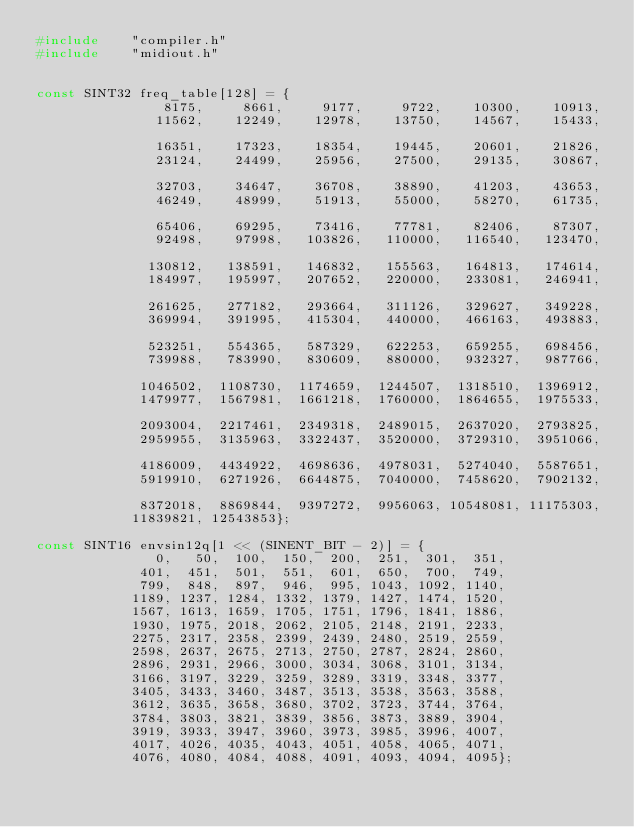<code> <loc_0><loc_0><loc_500><loc_500><_C_>#include	"compiler.h"
#include	"midiout.h"


const SINT32 freq_table[128] = {
			    8175,     8661,     9177,     9722,    10300,    10913,
			   11562,    12249,    12978,    13750,    14567,    15433,

			   16351,    17323,    18354,    19445,    20601,    21826,
			   23124,    24499,    25956,    27500,    29135,    30867,

			   32703,    34647,    36708,    38890,    41203,    43653,
			   46249,    48999,    51913,    55000,    58270,    61735,

			   65406,    69295,    73416,    77781,    82406,    87307,
			   92498,    97998,   103826,   110000,   116540,   123470,

			  130812,   138591,   146832,   155563,   164813,   174614,
			  184997,   195997,   207652,   220000,   233081,   246941,

			  261625,   277182,   293664,   311126,   329627,   349228,
			  369994,   391995,   415304,   440000,   466163,   493883,

			  523251,   554365,   587329,   622253,   659255,   698456,
			  739988,   783990,   830609,   880000,   932327,   987766,

			 1046502,  1108730,  1174659,  1244507,  1318510,  1396912,
			 1479977,  1567981,  1661218,  1760000,  1864655,  1975533,

			 2093004,  2217461,  2349318,  2489015,  2637020,  2793825,
			 2959955,  3135963,  3322437,  3520000,  3729310,  3951066,

			 4186009,  4434922,  4698636,  4978031,  5274040,  5587651,
			 5919910,  6271926,  6644875,  7040000,  7458620,  7902132,

			 8372018,  8869844,  9397272,  9956063, 10548081, 11175303,
			11839821, 12543853};

const SINT16 envsin12q[1 << (SINENT_BIT - 2)] = {
			   0,   50,  100,  150,  200,  251,  301,  351,
			 401,  451,  501,  551,  601,  650,  700,  749,
			 799,  848,  897,  946,  995, 1043, 1092, 1140,
			1189, 1237, 1284, 1332, 1379, 1427, 1474, 1520,
			1567, 1613, 1659, 1705, 1751, 1796, 1841, 1886,
			1930, 1975, 2018, 2062, 2105, 2148, 2191, 2233,
			2275, 2317, 2358, 2399, 2439, 2480, 2519, 2559,
			2598, 2637, 2675, 2713, 2750, 2787, 2824, 2860,
			2896, 2931, 2966, 3000, 3034, 3068, 3101, 3134,
			3166, 3197, 3229, 3259, 3289, 3319, 3348, 3377,
			3405, 3433, 3460, 3487, 3513, 3538, 3563, 3588,
			3612, 3635, 3658, 3680, 3702, 3723, 3744, 3764,
			3784, 3803, 3821, 3839, 3856, 3873, 3889, 3904,
			3919, 3933, 3947, 3960, 3973, 3985, 3996, 4007,
			4017, 4026, 4035, 4043, 4051, 4058, 4065, 4071,
			4076, 4080, 4084, 4088, 4091, 4093, 4094, 4095};
</code> 